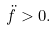<formula> <loc_0><loc_0><loc_500><loc_500>\ddot { f } > 0 .</formula> 